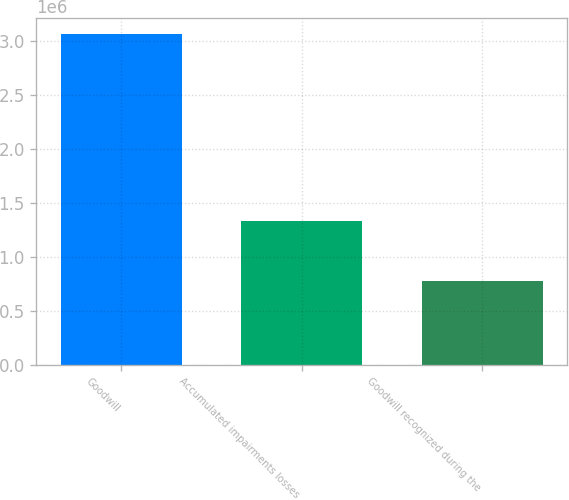Convert chart to OTSL. <chart><loc_0><loc_0><loc_500><loc_500><bar_chart><fcel>Goodwill<fcel>Accumulated impairments losses<fcel>Goodwill recognized during the<nl><fcel>3.06352e+06<fcel>1.32742e+06<fcel>775154<nl></chart> 